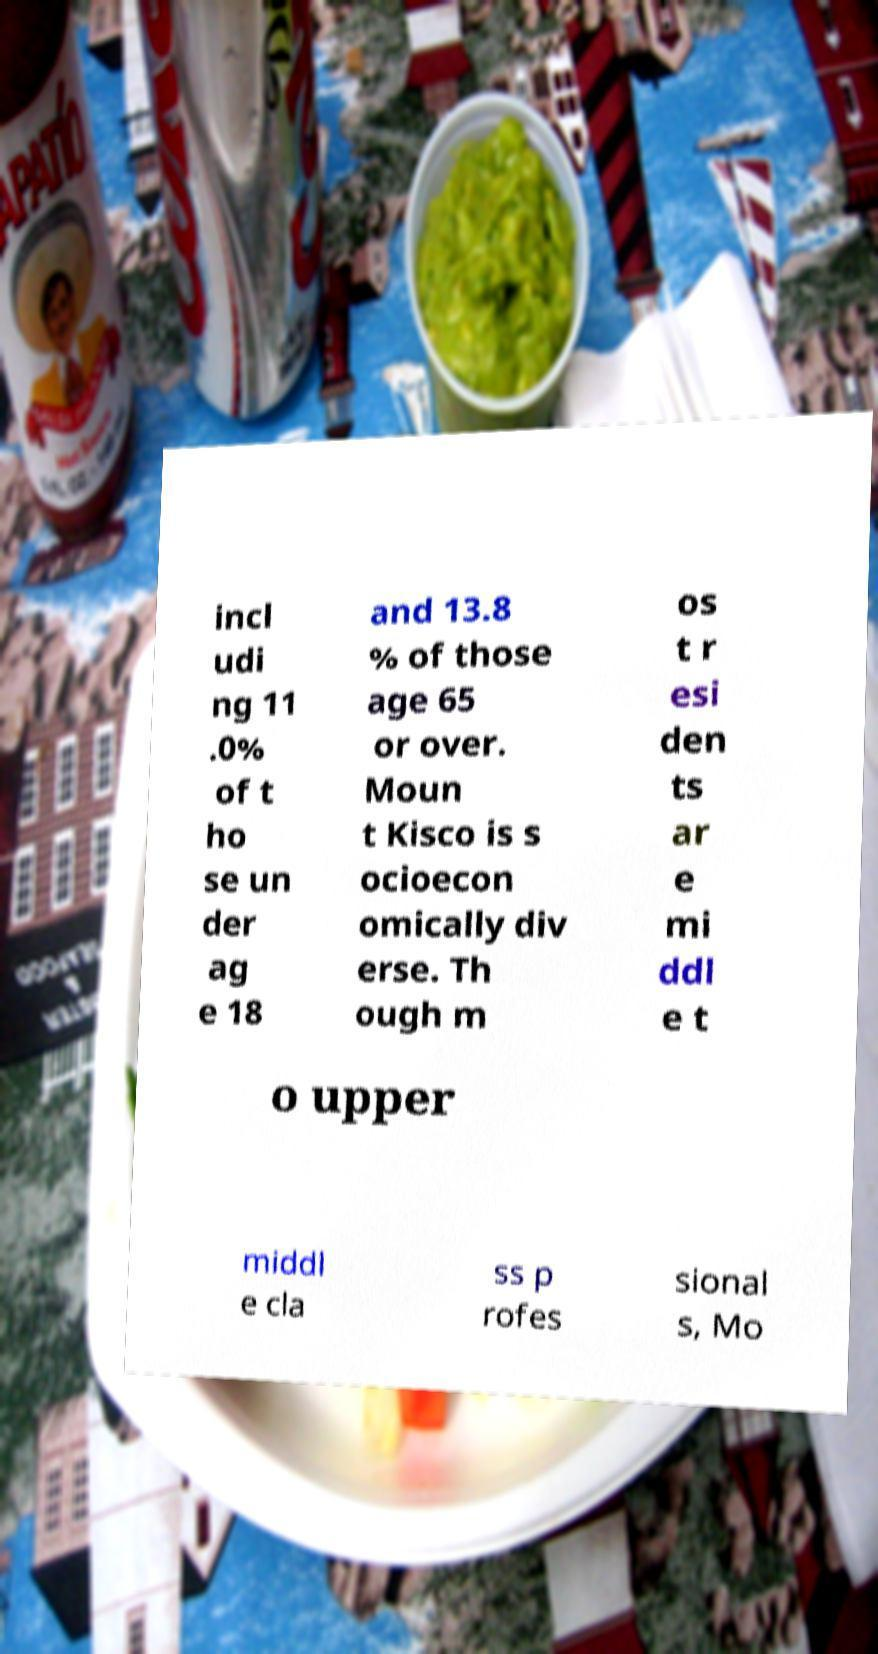There's text embedded in this image that I need extracted. Can you transcribe it verbatim? incl udi ng 11 .0% of t ho se un der ag e 18 and 13.8 % of those age 65 or over. Moun t Kisco is s ocioecon omically div erse. Th ough m os t r esi den ts ar e mi ddl e t o upper middl e cla ss p rofes sional s, Mo 